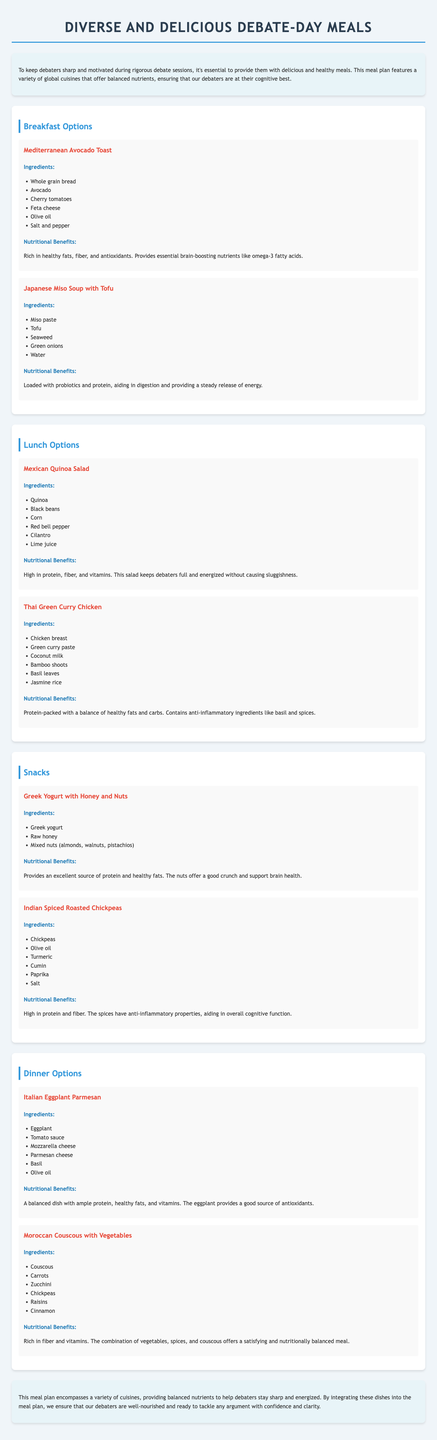What is the title of the document? The title of the document is prominently displayed at the top, serving as the main heading.
Answer: Diverse and Delicious Debate-Day Meals How many breakfast options are listed? The document categorizes meals into sections, and the Breakfast Options section contains a specific number of dishes.
Answer: 2 What is one ingredient in the Mediterranean Avocado Toast? The document provides a list of ingredients for each dish; one is highlighted for the Mediterranean Avocado Toast.
Answer: Avocado What are the nutritional benefits of the Mexican Quinoa Salad? The document describes the nutritional benefits of the dish, summarizing its health benefits.
Answer: High in protein, fiber, and vitamins Which cuisine is the Thai Green Curry Chicken from? The dish is categorized by its cuisine, which is highlighted in the title of the dish itself.
Answer: Thai What snack is made with Greek yogurt? The snack section lists various snacks, naming one that features Greek yogurt as a primary ingredient.
Answer: Greek Yogurt with Honey and Nuts What is one benefit of eating Mediterranean Avocado Toast? Nutritional benefits are specified for each meal, including Mediterranean Avocado Toast.
Answer: Provides essential brain-boosting nutrients like omega-3 fatty acids What type of dish is the Moroccan Couscous with Vegetables? The document categorizes each dish under meal options; this one falls under dinner.
Answer: Dinner How does the meal plan aim to assist debaters? The introduction and conclusion outline the purpose and goals of the meal plan regarding debaters.
Answer: To keep debaters sharp and motivated What is a key characteristic of Indian Spiced Roasted Chickpeas? The document provides a description highlighting significant properties or nutritional aspects of the dish.
Answer: High in protein and fiber 